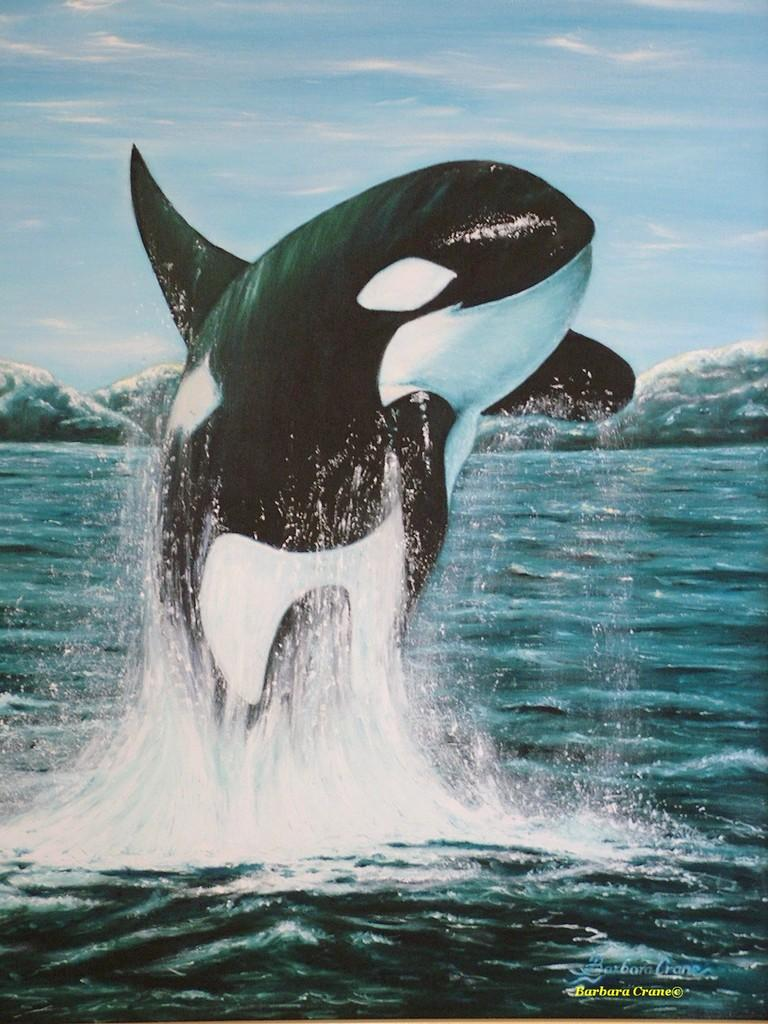What type of animal can be seen in the river in the image? There is a dolphin in the river in the image. What type of metal can be seen in the image? There is no metal present in the image; it features a dolphin in a river. Is there a cart visible in the image? No, there is no cart present in the image. 